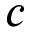Convert formula to latex. <formula><loc_0><loc_0><loc_500><loc_500>c</formula> 